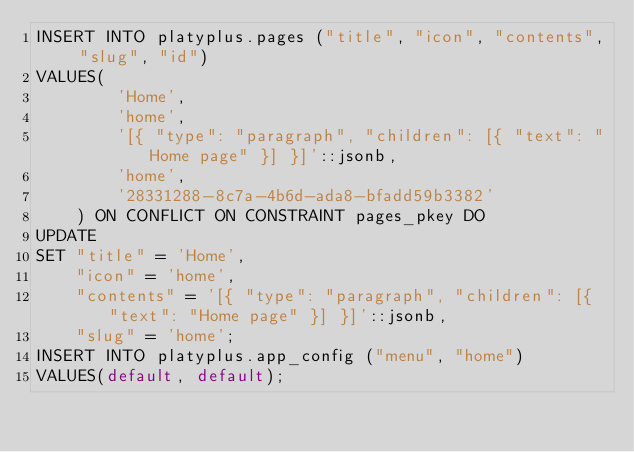Convert code to text. <code><loc_0><loc_0><loc_500><loc_500><_SQL_>INSERT INTO platyplus.pages ("title", "icon", "contents", "slug", "id")
VALUES(
        'Home',
        'home',
        '[{ "type": "paragraph", "children": [{ "text": "Home page" }] }]'::jsonb,
        'home',
        '28331288-8c7a-4b6d-ada8-bfadd59b3382'
    ) ON CONFLICT ON CONSTRAINT pages_pkey DO
UPDATE
SET "title" = 'Home',
    "icon" = 'home',
    "contents" = '[{ "type": "paragraph", "children": [{ "text": "Home page" }] }]'::jsonb,
    "slug" = 'home';
INSERT INTO platyplus.app_config ("menu", "home")
VALUES(default, default);</code> 